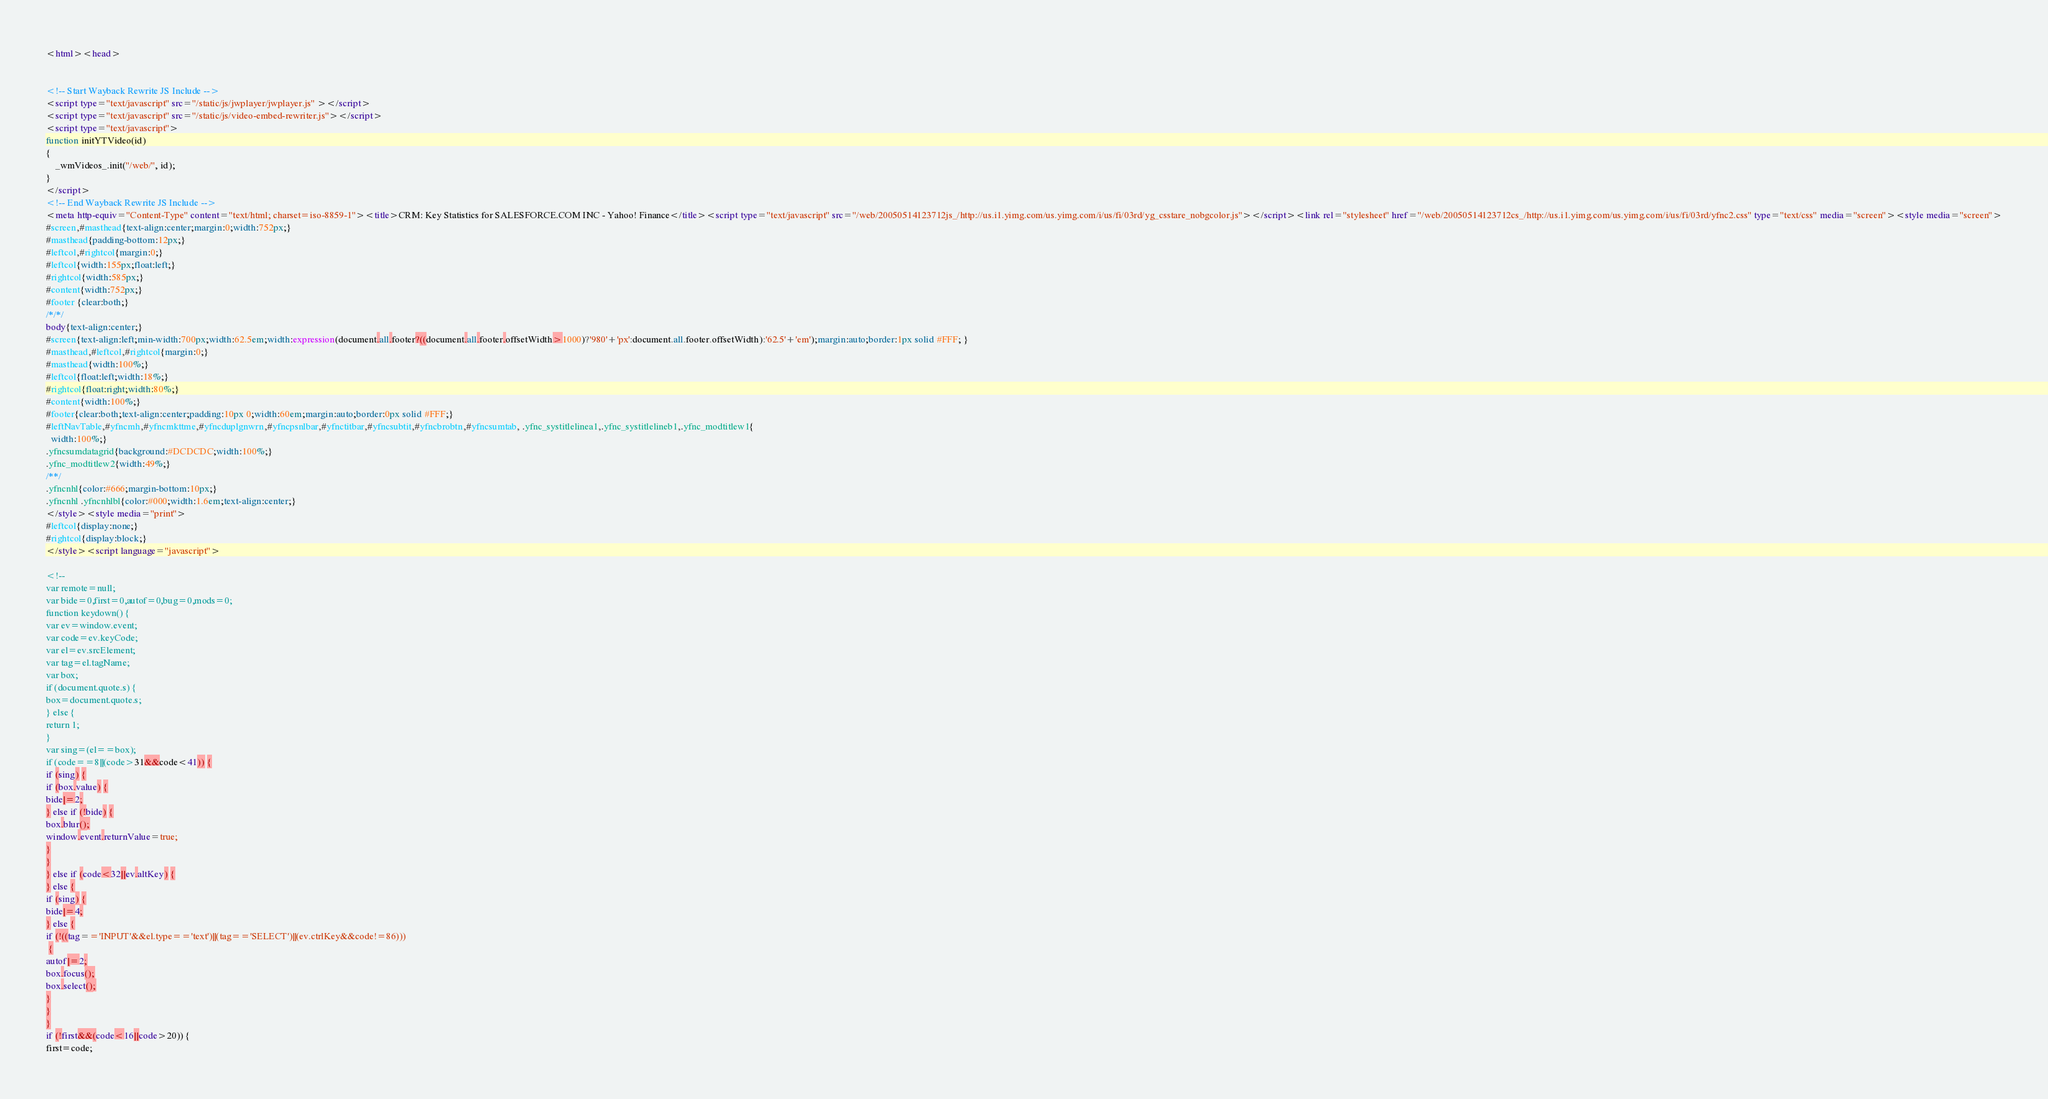Convert code to text. <code><loc_0><loc_0><loc_500><loc_500><_HTML_><html><head>


<!-- Start Wayback Rewrite JS Include -->
<script type="text/javascript" src="/static/js/jwplayer/jwplayer.js" ></script>
<script type="text/javascript" src="/static/js/video-embed-rewriter.js"></script>
<script type="text/javascript">
function initYTVideo(id)
{
	_wmVideos_.init("/web/", id);
}
</script>
<!-- End Wayback Rewrite JS Include -->
<meta http-equiv="Content-Type" content="text/html; charset=iso-8859-1"><title>CRM: Key Statistics for SALESFORCE.COM INC - Yahoo! Finance</title><script type="text/javascript" src="/web/20050514123712js_/http://us.i1.yimg.com/us.yimg.com/i/us/fi/03rd/yg_csstare_nobgcolor.js"></script><link rel="stylesheet" href="/web/20050514123712cs_/http://us.i1.yimg.com/us.yimg.com/i/us/fi/03rd/yfnc2.css" type="text/css" media="screen"><style media="screen">
#screen,#masthead{text-align:center;margin:0;width:752px;}
#masthead{padding-bottom:12px;}
#leftcol,#rightcol{margin:0;}
#leftcol{width:155px;float:left;}
#rightcol{width:585px;}
#content{width:752px;}
#footer {clear:both;}
/*/*/
body{text-align:center;}
#screen{text-align:left;min-width:700px;width:62.5em;width:expression(document.all.footer?((document.all.footer.offsetWidth>1000)?'980'+'px':document.all.footer.offsetWidth):'62.5'+'em');margin:auto;border:1px solid #FFF; }
#masthead,#leftcol,#rightcol{margin:0;}
#masthead{width:100%;}
#leftcol{float:left;width:18%;}
#rightcol{float:right;width:80%;}
#content{width:100%;}
#footer{clear:both;text-align:center;padding:10px 0;width:60em;margin:auto;border:0px solid #FFF;}
#leftNavTable,#yfncmh,#yfncmkttme,#yfncduplgnwrn,#yfncpsnlbar,#yfnctitbar,#yfncsubtit,#yfncbrobtn,#yfncsumtab, .yfnc_systitlelinea1,.yfnc_systitlelineb1,.yfnc_modtitlew1{
  width:100%;}
.yfncsumdatagrid{background:#DCDCDC;width:100%;}
.yfnc_modtitlew2{width:49%;}
/**/
.yfncnhl{color:#666;margin-bottom:10px;}
.yfncnhl .yfncnhlbl{color:#000;width:1.6em;text-align:center;}
</style><style media="print">
#leftcol{display:none;}
#rightcol{display:block;}
</style><script language="javascript">

<!--
var remote=null;
var bide=0,first=0,autof=0,bug=0,mods=0;
function keydown() {
var ev=window.event;
var code=ev.keyCode;
var el=ev.srcElement;
var tag=el.tagName;
var box;
if (document.quote.s) {
box=document.quote.s;
} else {
return 1;
}
var sing=(el==box);
if (code==8||(code>31&&code<41)) {
if (sing) {
if (box.value) {
bide|=2;
} else if (!bide) {
box.blur();
window.event.returnValue=true;
}
}
} else if (code<32||ev.altKey) {
} else {
if (sing) {
bide|=4;
} else {
if (!((tag=='INPUT'&&el.type=='text')||(tag=='SELECT')||(ev.ctrlKey&&code!=86)))
 {
autof|=2;
box.focus();
box.select();
}
}
}
if (!first&&(code<16||code>20)) {
first=code;</code> 